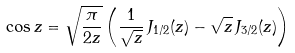<formula> <loc_0><loc_0><loc_500><loc_500>\cos z = \sqrt { \frac { \pi } { 2 z } } \left ( \frac { 1 } { \sqrt { z } } \, J _ { 1 / 2 } ( z ) - \sqrt { z } \, J _ { 3 / 2 } ( z ) \right )</formula> 